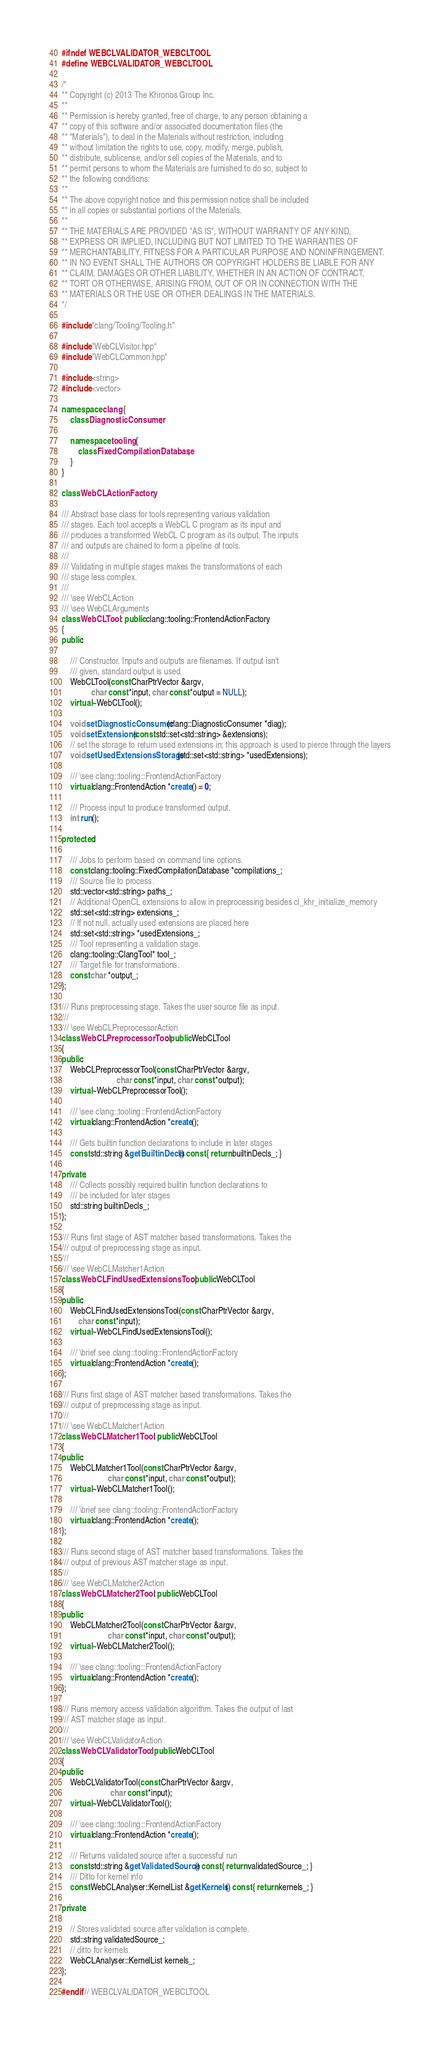<code> <loc_0><loc_0><loc_500><loc_500><_C++_>#ifndef WEBCLVALIDATOR_WEBCLTOOL
#define WEBCLVALIDATOR_WEBCLTOOL

/*
** Copyright (c) 2013 The Khronos Group Inc.
**
** Permission is hereby granted, free of charge, to any person obtaining a
** copy of this software and/or associated documentation files (the
** "Materials"), to deal in the Materials without restriction, including
** without limitation the rights to use, copy, modify, merge, publish,
** distribute, sublicense, and/or sell copies of the Materials, and to
** permit persons to whom the Materials are furnished to do so, subject to
** the following conditions:
**
** The above copyright notice and this permission notice shall be included
** in all copies or substantial portions of the Materials.
**
** THE MATERIALS ARE PROVIDED "AS IS", WITHOUT WARRANTY OF ANY KIND,
** EXPRESS OR IMPLIED, INCLUDING BUT NOT LIMITED TO THE WARRANTIES OF
** MERCHANTABILITY, FITNESS FOR A PARTICULAR PURPOSE AND NONINFRINGEMENT.
** IN NO EVENT SHALL THE AUTHORS OR COPYRIGHT HOLDERS BE LIABLE FOR ANY
** CLAIM, DAMAGES OR OTHER LIABILITY, WHETHER IN AN ACTION OF CONTRACT,
** TORT OR OTHERWISE, ARISING FROM, OUT OF OR IN CONNECTION WITH THE
** MATERIALS OR THE USE OR OTHER DEALINGS IN THE MATERIALS.
*/

#include "clang/Tooling/Tooling.h"

#include "WebCLVisitor.hpp"
#include "WebCLCommon.hpp"

#include <string>
#include <vector>

namespace clang {
    class DiagnosticConsumer;

    namespace tooling {
        class FixedCompilationDatabase;
    }
}

class WebCLActionFactory;

/// Abstract base class for tools representing various validation
/// stages. Each tool accepts a WebCL C program as its input and
/// produces a transformed WebCL C program as its output. The inputs
/// and outputs are chained to form a pipeline of tools.
///
/// Validating in multiple stages makes the transformations of each
/// stage less complex.
///
/// \see WebCLAction
/// \see WebCLArguments
class WebCLTool : public clang::tooling::FrontendActionFactory
{
public:

    /// Constructor. Inputs and outputs are filenames. If output isn't
    /// given, standard output is used.
    WebCLTool(const CharPtrVector &argv,
              char const *input, char const *output = NULL);
    virtual ~WebCLTool();

    void setDiagnosticConsumer(clang::DiagnosticConsumer *diag);
    void setExtensions(const std::set<std::string> &extensions);
    // set the storage to return used extensions in; this approach is used to pierce through the layers
    void setUsedExtensionsStorage(std::set<std::string> *usedExtensions);

    /// \see clang::tooling::FrontendActionFactory
    virtual clang::FrontendAction *create() = 0;

    /// Process input to produce transformed output.
    int run();

protected:

    /// Jobs to perform based on command line options.
    const clang::tooling::FixedCompilationDatabase *compilations_;
    /// Source file to process.
    std::vector<std::string> paths_;
    // Additional OpenCL extensions to allow in preprocessing besides cl_khr_initialize_memory
    std::set<std::string> extensions_;
    // If not null, actually used extensions are placed here
    std::set<std::string> *usedExtensions_;
    /// Tool representing a validation stage.
    clang::tooling::ClangTool* tool_;
    /// Target file for transformations.
    const char *output_;
};

/// Runs preprocessing stage. Takes the user source file as input.
///
/// \see WebCLPreprocessorAction
class WebCLPreprocessorTool : public WebCLTool
{
public:
    WebCLPreprocessorTool(const CharPtrVector &argv,
                          char const *input, char const *output);
    virtual ~WebCLPreprocessorTool();

    /// \see clang::tooling::FrontendActionFactory
    virtual clang::FrontendAction *create();

    /// Gets builtin function declarations to include in later stages
    const std::string &getBuiltinDecls() const { return builtinDecls_; }

private:
    /// Collects possibly required builtin function declarations to
    /// be included for later stages
    std::string builtinDecls_;
};

/// Runs first stage of AST matcher based transformations. Takes the
/// output of preprocessing stage as input.
///
/// \see WebCLMatcher1Action
class WebCLFindUsedExtensionsTool : public WebCLTool
{
public:
    WebCLFindUsedExtensionsTool(const CharPtrVector &argv,
        char const *input);
    virtual ~WebCLFindUsedExtensionsTool();

    /// \brief see clang::tooling::FrontendActionFactory
    virtual clang::FrontendAction *create();
};

/// Runs first stage of AST matcher based transformations. Takes the
/// output of preprocessing stage as input.
///
/// \see WebCLMatcher1Action
class WebCLMatcher1Tool : public WebCLTool
{
public:
    WebCLMatcher1Tool(const CharPtrVector &argv,
                      char const *input, char const *output);
    virtual ~WebCLMatcher1Tool();

    /// \brief see clang::tooling::FrontendActionFactory
    virtual clang::FrontendAction *create();
};

/// Runs second stage of AST matcher based transformations. Takes the
/// output of previous AST matcher stage as input.
///
/// \see WebCLMatcher2Action
class WebCLMatcher2Tool : public WebCLTool
{
public:
    WebCLMatcher2Tool(const CharPtrVector &argv,
                      char const *input, char const *output);
    virtual ~WebCLMatcher2Tool();

    /// \see clang::tooling::FrontendActionFactory
    virtual clang::FrontendAction *create();
};

/// Runs memory access validation algorithm. Takes the output of last
/// AST matcher stage as input.
///
/// \see WebCLValidatorAction
class WebCLValidatorTool : public WebCLTool
{
public:
    WebCLValidatorTool(const CharPtrVector &argv,
                       char const *input);
    virtual ~WebCLValidatorTool();

    /// \see clang::tooling::FrontendActionFactory
    virtual clang::FrontendAction *create();

    /// Returns validated source after a successful run
    const std::string &getValidatedSource() const { return validatedSource_; }
    /// Ditto for kernel info
    const WebCLAnalyser::KernelList &getKernels() const { return kernels_; }

private:

    // Stores validated source after validation is complete.
    std::string validatedSource_;
    // ditto for kernels
    WebCLAnalyser::KernelList kernels_;
};

#endif // WEBCLVALIDATOR_WEBCLTOOL
</code> 